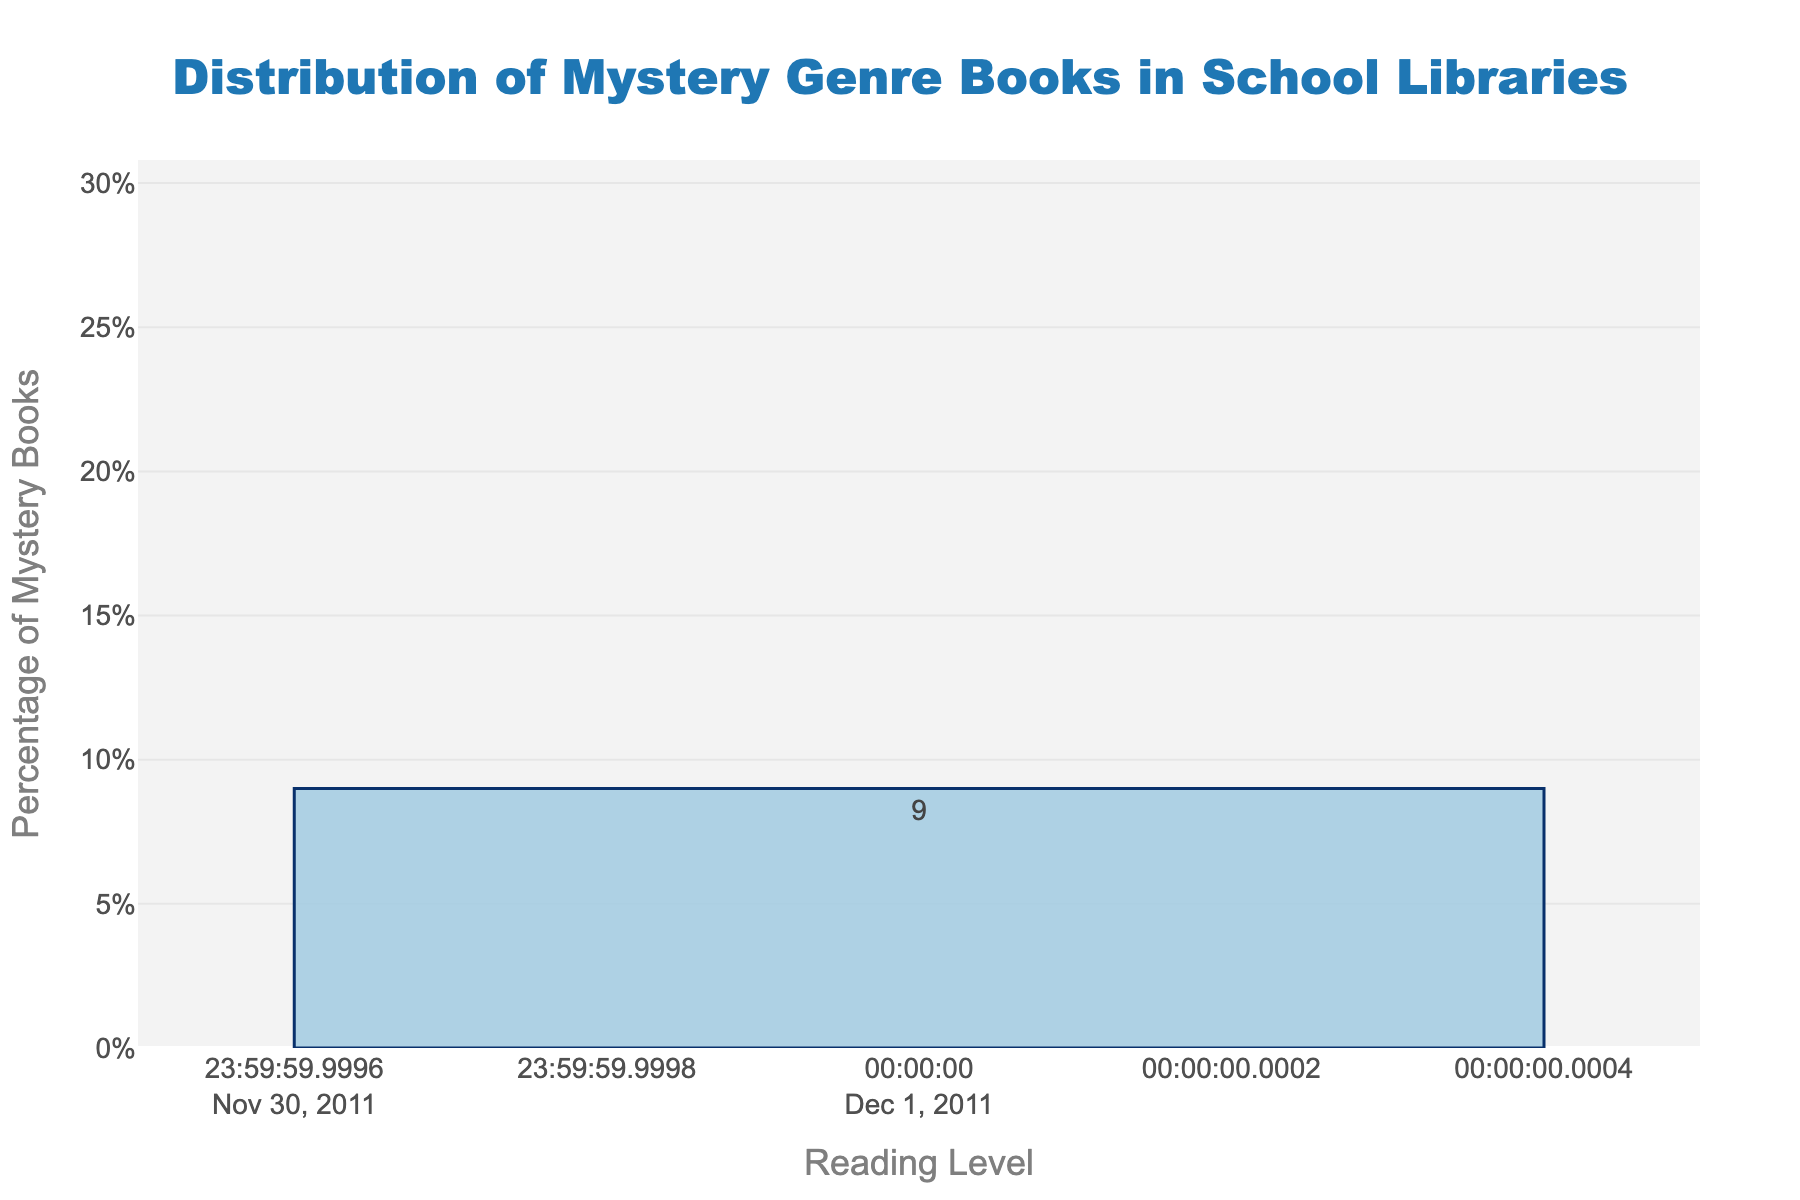What reading level has the highest percentage of mystery books? Looking at the height of the bars, the highest bar represents the 7-8 reading level. The percentage is indicated by the number on top of the bar, which shows 28%.
Answer: 7-8 Which reading level has the lowest percentage of mystery books? The shortest bar represents the K-2 reading level. The percentage on top of this bar is 8%, indicating it has the lowest percentage.
Answer: K-2 How much higher is the percentage of mystery books for the 5-6 reading level compared to the K-2 reading level? The percentage for the 5-6 reading level is 22%, while it is 8% for the K-2 reading level. The difference is calculated as 22% - 8% = 14%.
Answer: 14% What is the total percentage of mystery books for reading levels K-2, 3-4, and 5-6 combined? To find the total percentage, we sum the percentages for K-2 (8%), 3-4 (15%), and 5-6 (22%): 8% + 15% + 22% = 45%.
Answer: 45% Which reading levels have a percentage of mystery books greater than 20%? The bars that extend above the 20% mark are labeled with the following percentages: 22% (5-6 level) and 28% (7-8 level). Therefore, the reading levels with percentages greater than 20% are 5-6 and 7-8.
Answer: 5-6, 7-8 What is the range of percentages of mystery books across all reading levels? The highest percentage is 28% (7-8 level) and the lowest percentage is 8% (K-2 level). The range is calculated as 28% - 8% = 20%.
Answer: 20% Is the percentage of mystery books for reading level 9-10 greater or less than the combined percentage for reading levels K-2 and 11-12? The percentage for reading level 9-10 is 18%, while the combined percentage for K-2 (8%) and 11-12 (9%) is 17% (8% + 9%). Thus, 18% is greater than 17%.
Answer: Greater 